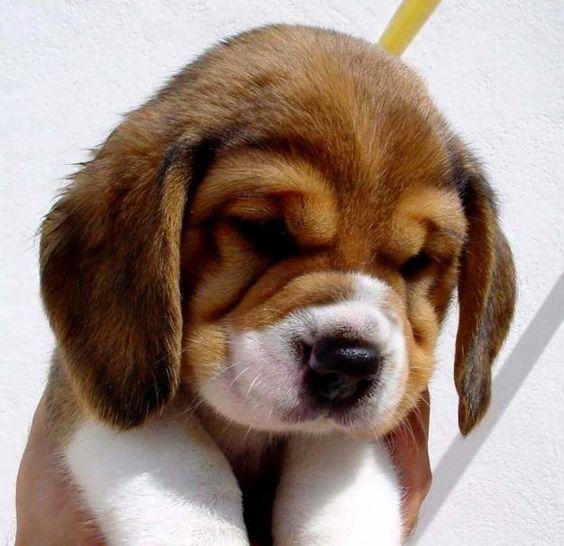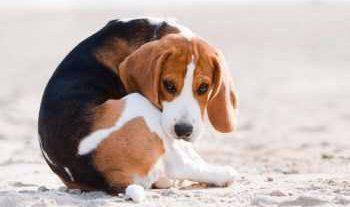The first image is the image on the left, the second image is the image on the right. For the images shown, is this caption "Each image shows exactly one beagle, but the beagle on the right is older with a longer muzzle and is posed on an outdoor surface." true? Answer yes or no. Yes. The first image is the image on the left, the second image is the image on the right. For the images displayed, is the sentence "The dog on the right is photographed in snow and has a white line going upwards from his nose to his forehead." factually correct? Answer yes or no. Yes. 